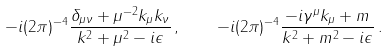Convert formula to latex. <formula><loc_0><loc_0><loc_500><loc_500>- i ( 2 \pi ) ^ { - 4 } { \frac { \delta _ { \mu \nu } + \mu ^ { - 2 } k _ { \mu } k _ { \nu } } { k ^ { 2 } + \mu ^ { 2 } - i \epsilon } } \, , \quad - i ( 2 \pi ) ^ { - 4 } { \frac { - i \gamma ^ { \mu } k _ { \mu } + m } { k ^ { 2 } + m ^ { 2 } - i \epsilon } } \, .</formula> 